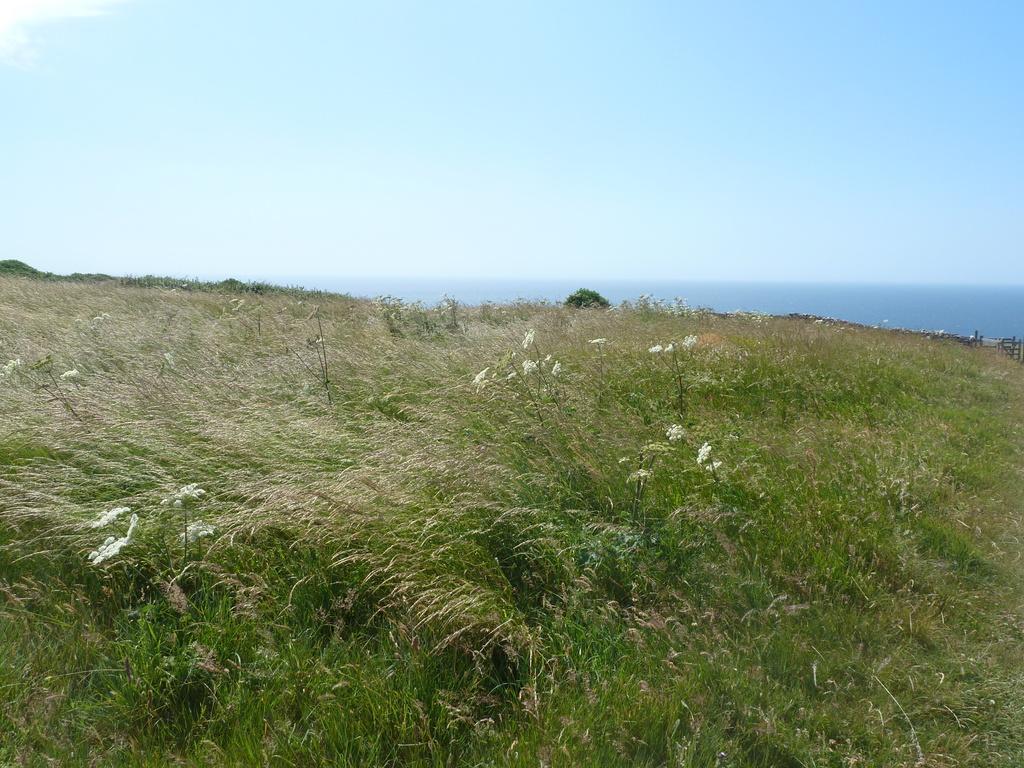Please provide a concise description of this image. In the image we can see the sky, plants, grass and flowers. 